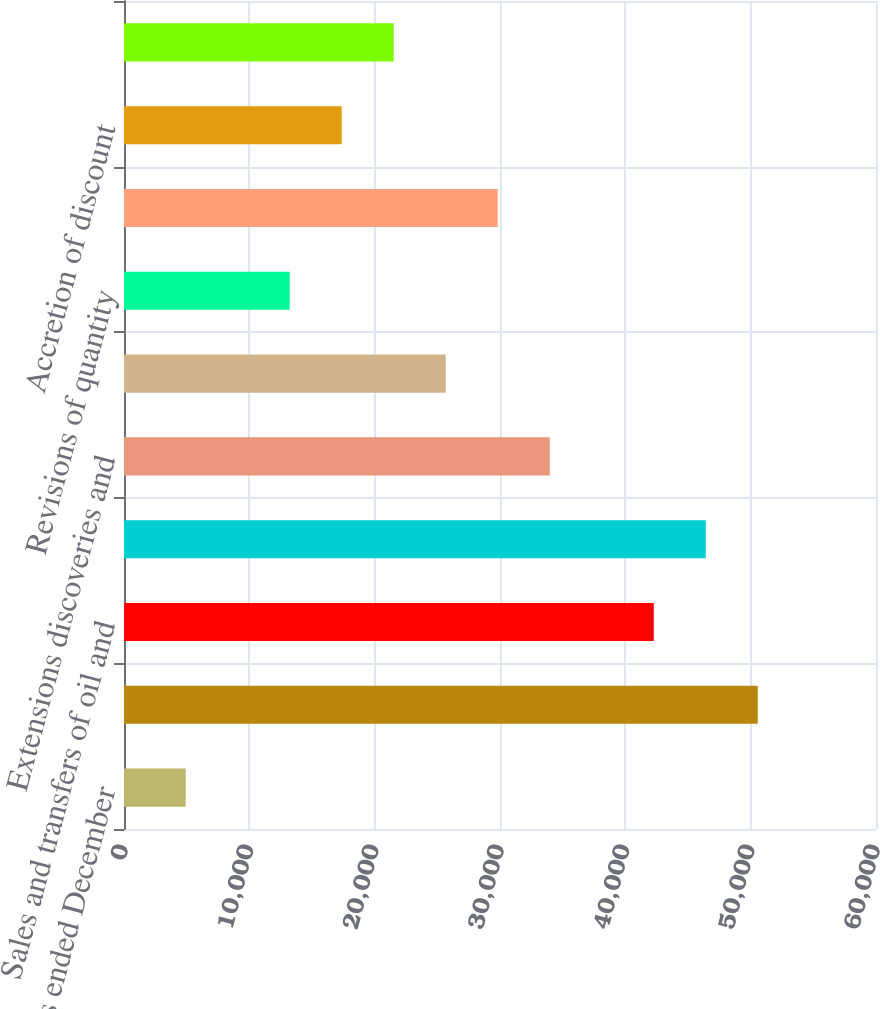Convert chart. <chart><loc_0><loc_0><loc_500><loc_500><bar_chart><fcel>For the years ended December<fcel>Beginning of year<fcel>Sales and transfers of oil and<fcel>Net change in prices received<fcel>Extensions discoveries and<fcel>Change in estimated future<fcel>Revisions of quantity<fcel>Development costs incurred<fcel>Accretion of discount<fcel>Net change in income taxes<nl><fcel>4922.4<fcel>50565.8<fcel>42267<fcel>46416.4<fcel>33968.2<fcel>25669.4<fcel>13221.2<fcel>29818.8<fcel>17370.6<fcel>21520<nl></chart> 